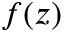Convert formula to latex. <formula><loc_0><loc_0><loc_500><loc_500>f ( z )</formula> 